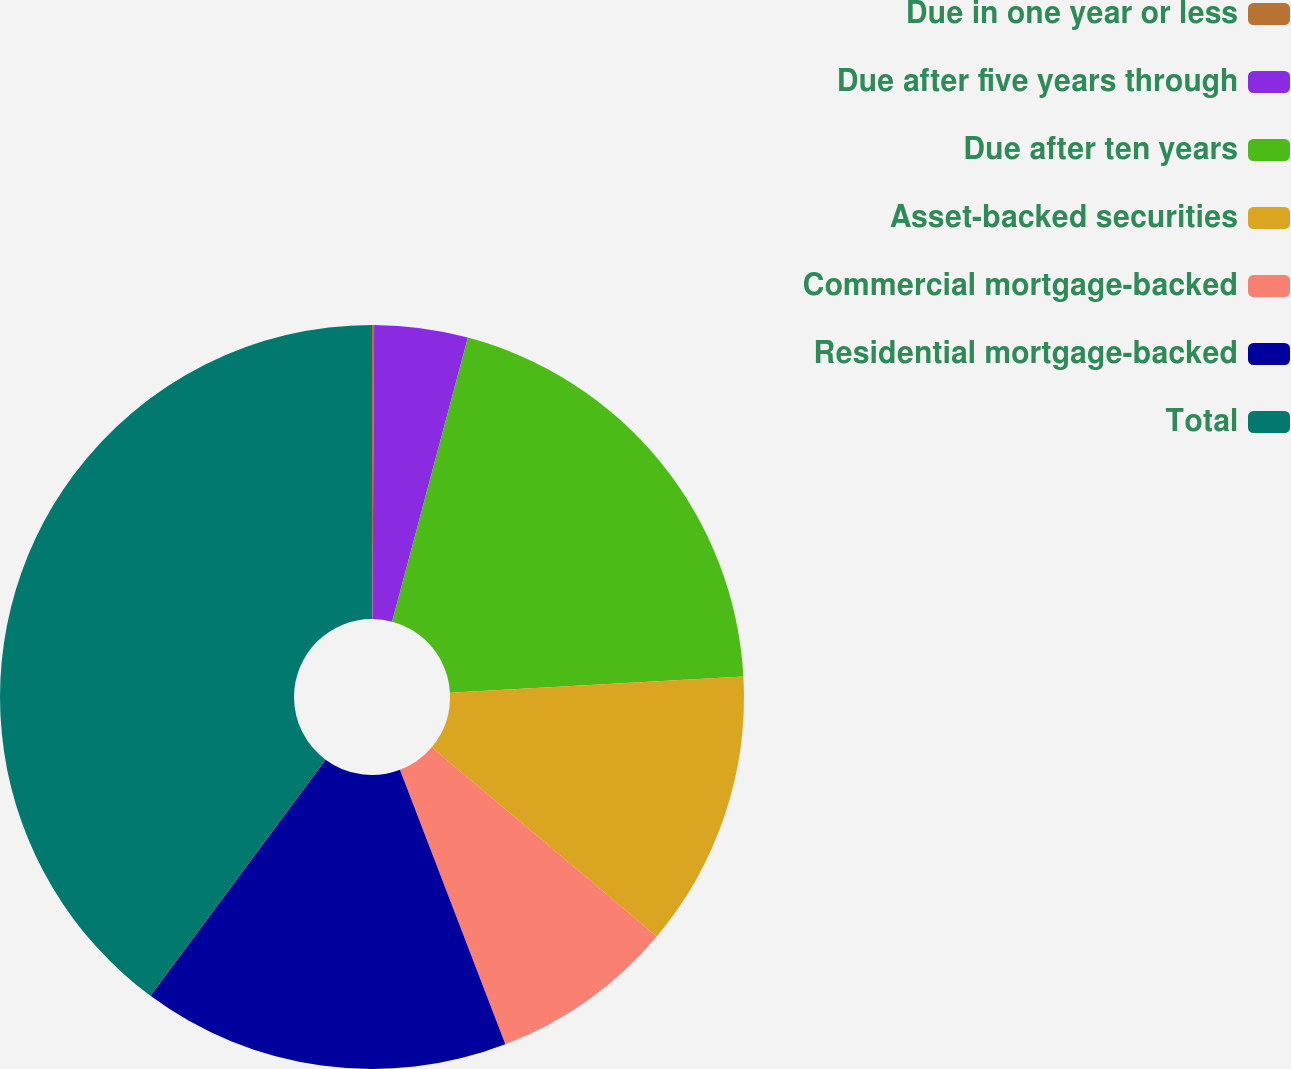Convert chart to OTSL. <chart><loc_0><loc_0><loc_500><loc_500><pie_chart><fcel>Due in one year or less<fcel>Due after five years through<fcel>Due after ten years<fcel>Asset-backed securities<fcel>Commercial mortgage-backed<fcel>Residential mortgage-backed<fcel>Total<nl><fcel>0.09%<fcel>4.06%<fcel>19.97%<fcel>12.01%<fcel>8.04%<fcel>15.99%<fcel>39.85%<nl></chart> 